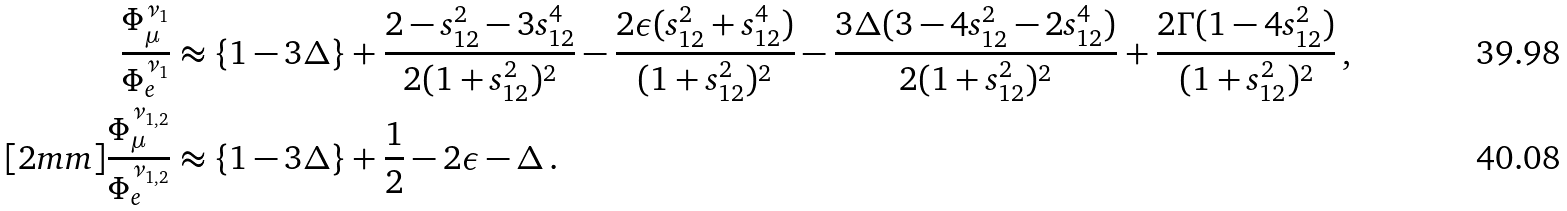Convert formula to latex. <formula><loc_0><loc_0><loc_500><loc_500>\frac { \Phi ^ { \nu _ { 1 } } _ { \mu } } { \Phi ^ { \nu _ { 1 } } _ { e } } & \approx \{ 1 - 3 \Delta \} + \frac { 2 - s _ { 1 2 } ^ { 2 } - 3 s _ { 1 2 } ^ { 4 } } { 2 ( 1 + s _ { 1 2 } ^ { 2 } ) ^ { 2 } } - \frac { 2 \epsilon ( s _ { 1 2 } ^ { 2 } + s _ { 1 2 } ^ { 4 } ) } { ( 1 + s _ { 1 2 } ^ { 2 } ) ^ { 2 } } - \frac { 3 \Delta ( 3 - 4 s _ { 1 2 } ^ { 2 } - 2 s _ { 1 2 } ^ { 4 } ) } { 2 ( 1 + s _ { 1 2 } ^ { 2 } ) ^ { 2 } } + \frac { 2 \Gamma ( 1 - 4 s _ { 1 2 } ^ { 2 } ) } { ( 1 + s _ { 1 2 } ^ { 2 } ) ^ { 2 } } \, , \\ [ 2 m m ] \frac { \Phi ^ { \nu _ { 1 , 2 } } _ { \mu } } { \Phi ^ { \nu _ { 1 , 2 } } _ { e } } & \approx \{ 1 - 3 \Delta \} + \frac { 1 } { 2 } - 2 \epsilon - \Delta \, .</formula> 